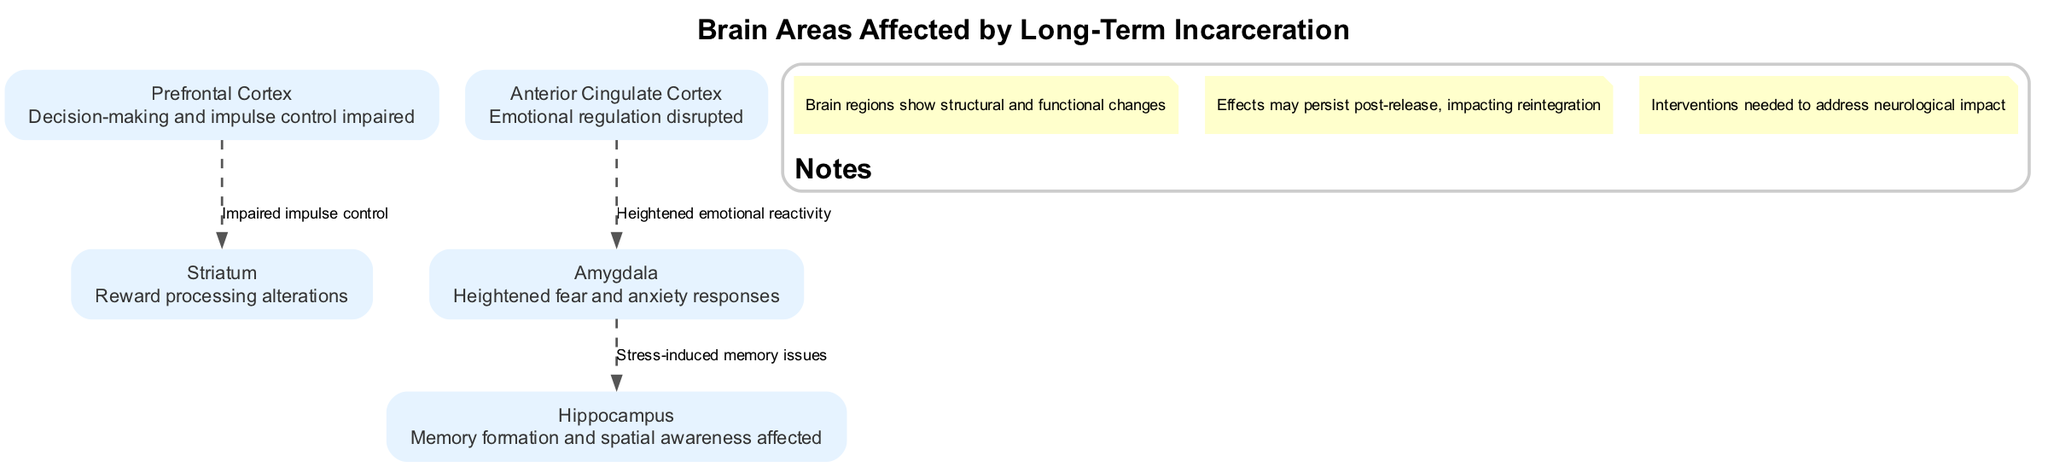What are the five brain areas highlighted in the diagram? The diagram lists five specific areas of the brain affected by long-term incarceration: Prefrontal Cortex, Amygdala, Hippocampus, Anterior Cingulate Cortex, and Striatum.
Answer: Prefrontal Cortex, Amygdala, Hippocampus, Anterior Cingulate Cortex, Striatum Which area is responsible for decision-making and impulse control? According to the diagram, the Prefrontal Cortex is described as being responsible for decision-making and impulse control.
Answer: Prefrontal Cortex What effect does incarceration have on the Amygdala? The diagram notes that the Amygdala shows heightened fear and anxiety responses due to incarceration, leading to a disordered emotional state.
Answer: Heightened fear and anxiety responses How many edges are there connecting the nodes in the diagram? The diagram displays three edges, which represent the relationships between the various brain areas affected by incarceration.
Answer: 3 What is the connection between the Prefrontal Cortex and the Striatum? The diagram indicates that the connection between the Prefrontal Cortex and the Striatum is described as "Impaired impulse control," showing how their interaction is affected by incarceration.
Answer: Impaired impulse control Which area is disrupted in emotional regulation? The diagram specifically states that the Anterior Cingulate Cortex is disrupted in terms of emotional regulation after long-term incarceration.
Answer: Anterior Cingulate Cortex What lasting effects may persist after release from incarceration? The diagram mentions that effects of incarceration may persist post-release, indicating prolonged impacts on mental health and societal reintegration.
Answer: Effects may persist post-release How does stress impact the Hippocampus according to the diagram? It is illustrated that stress from incarceration can lead to memory issues in the Hippocampus, highlighting one of the consequences of long-term confinement.
Answer: Stress-induced memory issues What types of interventions are suggested in the diagram? The diagram notes that interventions are necessary to address the neurological impacts of long-term incarceration, indicating a need for planned rehabilitation efforts.
Answer: Interventions needed to address neurological impact 